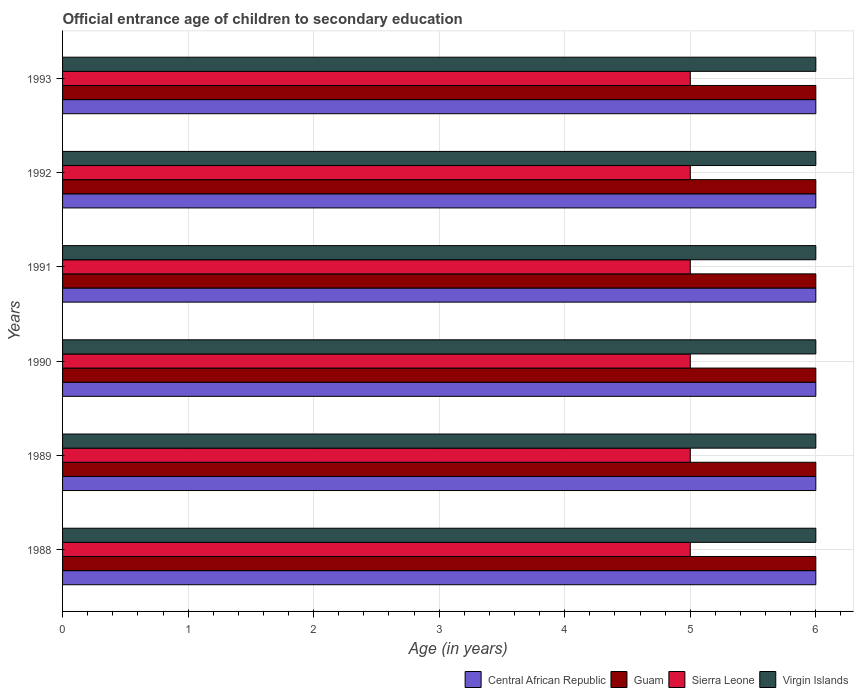How many different coloured bars are there?
Your answer should be compact. 4. Are the number of bars per tick equal to the number of legend labels?
Keep it short and to the point. Yes. How many bars are there on the 2nd tick from the top?
Make the answer very short. 4. How many bars are there on the 1st tick from the bottom?
Make the answer very short. 4. What is the label of the 3rd group of bars from the top?
Ensure brevity in your answer.  1991. In how many cases, is the number of bars for a given year not equal to the number of legend labels?
Ensure brevity in your answer.  0. What is the secondary school starting age of children in Sierra Leone in 1993?
Give a very brief answer. 5. Across all years, what is the maximum secondary school starting age of children in Sierra Leone?
Offer a terse response. 5. Across all years, what is the minimum secondary school starting age of children in Guam?
Make the answer very short. 6. In which year was the secondary school starting age of children in Sierra Leone maximum?
Keep it short and to the point. 1988. What is the total secondary school starting age of children in Virgin Islands in the graph?
Provide a short and direct response. 36. What is the difference between the secondary school starting age of children in Guam in 1989 and that in 1993?
Provide a succinct answer. 0. What is the difference between the secondary school starting age of children in Virgin Islands in 1992 and the secondary school starting age of children in Central African Republic in 1989?
Offer a very short reply. 0. In the year 1990, what is the difference between the secondary school starting age of children in Sierra Leone and secondary school starting age of children in Central African Republic?
Your answer should be compact. -1. In how many years, is the secondary school starting age of children in Guam greater than 3.2 years?
Offer a very short reply. 6. What is the ratio of the secondary school starting age of children in Virgin Islands in 1990 to that in 1991?
Make the answer very short. 1. Is the difference between the secondary school starting age of children in Sierra Leone in 1989 and 1990 greater than the difference between the secondary school starting age of children in Central African Republic in 1989 and 1990?
Give a very brief answer. No. Is the sum of the secondary school starting age of children in Guam in 1989 and 1991 greater than the maximum secondary school starting age of children in Central African Republic across all years?
Your response must be concise. Yes. Is it the case that in every year, the sum of the secondary school starting age of children in Virgin Islands and secondary school starting age of children in Central African Republic is greater than the sum of secondary school starting age of children in Sierra Leone and secondary school starting age of children in Guam?
Offer a terse response. No. What does the 1st bar from the top in 1991 represents?
Offer a very short reply. Virgin Islands. What does the 3rd bar from the bottom in 1989 represents?
Ensure brevity in your answer.  Sierra Leone. Is it the case that in every year, the sum of the secondary school starting age of children in Central African Republic and secondary school starting age of children in Sierra Leone is greater than the secondary school starting age of children in Virgin Islands?
Keep it short and to the point. Yes. How many bars are there?
Ensure brevity in your answer.  24. How many years are there in the graph?
Your answer should be compact. 6. What is the difference between two consecutive major ticks on the X-axis?
Ensure brevity in your answer.  1. How are the legend labels stacked?
Offer a terse response. Horizontal. What is the title of the graph?
Provide a succinct answer. Official entrance age of children to secondary education. Does "Palau" appear as one of the legend labels in the graph?
Provide a short and direct response. No. What is the label or title of the X-axis?
Offer a terse response. Age (in years). What is the Age (in years) of Central African Republic in 1988?
Provide a succinct answer. 6. What is the Age (in years) in Guam in 1988?
Your answer should be compact. 6. What is the Age (in years) in Central African Republic in 1989?
Keep it short and to the point. 6. What is the Age (in years) of Guam in 1990?
Your answer should be compact. 6. What is the Age (in years) of Central African Republic in 1991?
Your response must be concise. 6. What is the Age (in years) of Sierra Leone in 1991?
Offer a terse response. 5. What is the Age (in years) of Central African Republic in 1992?
Make the answer very short. 6. What is the Age (in years) in Guam in 1992?
Ensure brevity in your answer.  6. What is the Age (in years) in Central African Republic in 1993?
Your answer should be very brief. 6. What is the Age (in years) in Guam in 1993?
Ensure brevity in your answer.  6. What is the Age (in years) in Sierra Leone in 1993?
Your answer should be very brief. 5. Across all years, what is the maximum Age (in years) in Guam?
Ensure brevity in your answer.  6. Across all years, what is the maximum Age (in years) in Sierra Leone?
Ensure brevity in your answer.  5. Across all years, what is the maximum Age (in years) in Virgin Islands?
Your answer should be compact. 6. Across all years, what is the minimum Age (in years) of Guam?
Ensure brevity in your answer.  6. What is the total Age (in years) of Central African Republic in the graph?
Provide a short and direct response. 36. What is the total Age (in years) of Sierra Leone in the graph?
Your answer should be compact. 30. What is the total Age (in years) in Virgin Islands in the graph?
Offer a terse response. 36. What is the difference between the Age (in years) of Central African Republic in 1988 and that in 1989?
Your answer should be very brief. 0. What is the difference between the Age (in years) of Virgin Islands in 1988 and that in 1989?
Keep it short and to the point. 0. What is the difference between the Age (in years) of Central African Republic in 1988 and that in 1990?
Provide a succinct answer. 0. What is the difference between the Age (in years) of Central African Republic in 1988 and that in 1991?
Offer a terse response. 0. What is the difference between the Age (in years) in Virgin Islands in 1988 and that in 1991?
Ensure brevity in your answer.  0. What is the difference between the Age (in years) of Central African Republic in 1988 and that in 1992?
Make the answer very short. 0. What is the difference between the Age (in years) in Sierra Leone in 1988 and that in 1992?
Offer a very short reply. 0. What is the difference between the Age (in years) in Central African Republic in 1988 and that in 1993?
Offer a terse response. 0. What is the difference between the Age (in years) of Guam in 1988 and that in 1993?
Make the answer very short. 0. What is the difference between the Age (in years) in Sierra Leone in 1988 and that in 1993?
Your response must be concise. 0. What is the difference between the Age (in years) in Guam in 1989 and that in 1990?
Make the answer very short. 0. What is the difference between the Age (in years) of Sierra Leone in 1989 and that in 1990?
Your answer should be compact. 0. What is the difference between the Age (in years) of Guam in 1989 and that in 1991?
Your answer should be very brief. 0. What is the difference between the Age (in years) in Sierra Leone in 1989 and that in 1991?
Offer a very short reply. 0. What is the difference between the Age (in years) of Virgin Islands in 1989 and that in 1991?
Your response must be concise. 0. What is the difference between the Age (in years) in Central African Republic in 1989 and that in 1992?
Your answer should be very brief. 0. What is the difference between the Age (in years) of Virgin Islands in 1989 and that in 1992?
Offer a terse response. 0. What is the difference between the Age (in years) in Guam in 1989 and that in 1993?
Ensure brevity in your answer.  0. What is the difference between the Age (in years) of Central African Republic in 1990 and that in 1991?
Offer a very short reply. 0. What is the difference between the Age (in years) in Central African Republic in 1990 and that in 1992?
Give a very brief answer. 0. What is the difference between the Age (in years) of Sierra Leone in 1990 and that in 1992?
Your response must be concise. 0. What is the difference between the Age (in years) in Virgin Islands in 1990 and that in 1992?
Your response must be concise. 0. What is the difference between the Age (in years) in Central African Republic in 1990 and that in 1993?
Offer a terse response. 0. What is the difference between the Age (in years) in Virgin Islands in 1990 and that in 1993?
Your response must be concise. 0. What is the difference between the Age (in years) of Guam in 1991 and that in 1992?
Keep it short and to the point. 0. What is the difference between the Age (in years) of Sierra Leone in 1991 and that in 1992?
Keep it short and to the point. 0. What is the difference between the Age (in years) of Guam in 1992 and that in 1993?
Your answer should be compact. 0. What is the difference between the Age (in years) in Sierra Leone in 1992 and that in 1993?
Provide a succinct answer. 0. What is the difference between the Age (in years) of Central African Republic in 1988 and the Age (in years) of Guam in 1989?
Your answer should be compact. 0. What is the difference between the Age (in years) of Central African Republic in 1988 and the Age (in years) of Virgin Islands in 1989?
Give a very brief answer. 0. What is the difference between the Age (in years) in Central African Republic in 1988 and the Age (in years) in Virgin Islands in 1990?
Offer a terse response. 0. What is the difference between the Age (in years) of Guam in 1988 and the Age (in years) of Sierra Leone in 1990?
Give a very brief answer. 1. What is the difference between the Age (in years) in Guam in 1988 and the Age (in years) in Virgin Islands in 1990?
Offer a terse response. 0. What is the difference between the Age (in years) in Sierra Leone in 1988 and the Age (in years) in Virgin Islands in 1990?
Your response must be concise. -1. What is the difference between the Age (in years) in Central African Republic in 1988 and the Age (in years) in Guam in 1991?
Your response must be concise. 0. What is the difference between the Age (in years) of Central African Republic in 1988 and the Age (in years) of Sierra Leone in 1991?
Ensure brevity in your answer.  1. What is the difference between the Age (in years) of Guam in 1988 and the Age (in years) of Sierra Leone in 1991?
Make the answer very short. 1. What is the difference between the Age (in years) of Guam in 1988 and the Age (in years) of Virgin Islands in 1991?
Offer a very short reply. 0. What is the difference between the Age (in years) of Central African Republic in 1988 and the Age (in years) of Guam in 1992?
Ensure brevity in your answer.  0. What is the difference between the Age (in years) in Central African Republic in 1988 and the Age (in years) in Sierra Leone in 1992?
Make the answer very short. 1. What is the difference between the Age (in years) of Central African Republic in 1988 and the Age (in years) of Virgin Islands in 1992?
Offer a terse response. 0. What is the difference between the Age (in years) of Guam in 1988 and the Age (in years) of Sierra Leone in 1992?
Your answer should be very brief. 1. What is the difference between the Age (in years) in Guam in 1988 and the Age (in years) in Virgin Islands in 1992?
Offer a very short reply. 0. What is the difference between the Age (in years) in Sierra Leone in 1988 and the Age (in years) in Virgin Islands in 1992?
Your response must be concise. -1. What is the difference between the Age (in years) in Central African Republic in 1988 and the Age (in years) in Sierra Leone in 1993?
Keep it short and to the point. 1. What is the difference between the Age (in years) in Guam in 1988 and the Age (in years) in Virgin Islands in 1993?
Offer a terse response. 0. What is the difference between the Age (in years) in Central African Republic in 1989 and the Age (in years) in Virgin Islands in 1990?
Offer a very short reply. 0. What is the difference between the Age (in years) in Central African Republic in 1989 and the Age (in years) in Sierra Leone in 1991?
Provide a short and direct response. 1. What is the difference between the Age (in years) in Central African Republic in 1989 and the Age (in years) in Virgin Islands in 1991?
Offer a terse response. 0. What is the difference between the Age (in years) of Central African Republic in 1989 and the Age (in years) of Guam in 1992?
Keep it short and to the point. 0. What is the difference between the Age (in years) of Guam in 1989 and the Age (in years) of Virgin Islands in 1992?
Your response must be concise. 0. What is the difference between the Age (in years) in Sierra Leone in 1989 and the Age (in years) in Virgin Islands in 1992?
Provide a short and direct response. -1. What is the difference between the Age (in years) of Central African Republic in 1989 and the Age (in years) of Guam in 1993?
Make the answer very short. 0. What is the difference between the Age (in years) of Central African Republic in 1989 and the Age (in years) of Virgin Islands in 1993?
Ensure brevity in your answer.  0. What is the difference between the Age (in years) of Guam in 1989 and the Age (in years) of Sierra Leone in 1993?
Offer a very short reply. 1. What is the difference between the Age (in years) of Sierra Leone in 1989 and the Age (in years) of Virgin Islands in 1993?
Offer a very short reply. -1. What is the difference between the Age (in years) in Central African Republic in 1990 and the Age (in years) in Guam in 1991?
Make the answer very short. 0. What is the difference between the Age (in years) in Central African Republic in 1990 and the Age (in years) in Sierra Leone in 1991?
Offer a terse response. 1. What is the difference between the Age (in years) in Central African Republic in 1990 and the Age (in years) in Virgin Islands in 1991?
Your response must be concise. 0. What is the difference between the Age (in years) of Guam in 1990 and the Age (in years) of Sierra Leone in 1991?
Your answer should be very brief. 1. What is the difference between the Age (in years) in Guam in 1990 and the Age (in years) in Virgin Islands in 1991?
Your answer should be very brief. 0. What is the difference between the Age (in years) of Sierra Leone in 1990 and the Age (in years) of Virgin Islands in 1991?
Provide a succinct answer. -1. What is the difference between the Age (in years) of Central African Republic in 1990 and the Age (in years) of Guam in 1992?
Offer a very short reply. 0. What is the difference between the Age (in years) in Central African Republic in 1990 and the Age (in years) in Sierra Leone in 1992?
Offer a very short reply. 1. What is the difference between the Age (in years) in Guam in 1990 and the Age (in years) in Sierra Leone in 1992?
Your answer should be compact. 1. What is the difference between the Age (in years) of Guam in 1990 and the Age (in years) of Virgin Islands in 1992?
Your answer should be very brief. 0. What is the difference between the Age (in years) in Sierra Leone in 1990 and the Age (in years) in Virgin Islands in 1992?
Provide a succinct answer. -1. What is the difference between the Age (in years) of Central African Republic in 1990 and the Age (in years) of Sierra Leone in 1993?
Ensure brevity in your answer.  1. What is the difference between the Age (in years) in Central African Republic in 1990 and the Age (in years) in Virgin Islands in 1993?
Keep it short and to the point. 0. What is the difference between the Age (in years) in Guam in 1991 and the Age (in years) in Sierra Leone in 1992?
Offer a terse response. 1. What is the difference between the Age (in years) in Sierra Leone in 1991 and the Age (in years) in Virgin Islands in 1992?
Your answer should be very brief. -1. What is the difference between the Age (in years) in Central African Republic in 1991 and the Age (in years) in Virgin Islands in 1993?
Keep it short and to the point. 0. What is the difference between the Age (in years) in Guam in 1991 and the Age (in years) in Sierra Leone in 1993?
Make the answer very short. 1. What is the difference between the Age (in years) of Guam in 1991 and the Age (in years) of Virgin Islands in 1993?
Your answer should be very brief. 0. What is the difference between the Age (in years) in Sierra Leone in 1991 and the Age (in years) in Virgin Islands in 1993?
Ensure brevity in your answer.  -1. What is the difference between the Age (in years) of Guam in 1992 and the Age (in years) of Sierra Leone in 1993?
Your response must be concise. 1. What is the difference between the Age (in years) of Sierra Leone in 1992 and the Age (in years) of Virgin Islands in 1993?
Make the answer very short. -1. What is the average Age (in years) of Guam per year?
Your answer should be very brief. 6. What is the average Age (in years) in Sierra Leone per year?
Ensure brevity in your answer.  5. In the year 1988, what is the difference between the Age (in years) in Guam and Age (in years) in Sierra Leone?
Give a very brief answer. 1. In the year 1988, what is the difference between the Age (in years) in Guam and Age (in years) in Virgin Islands?
Make the answer very short. 0. In the year 1988, what is the difference between the Age (in years) in Sierra Leone and Age (in years) in Virgin Islands?
Ensure brevity in your answer.  -1. In the year 1989, what is the difference between the Age (in years) of Central African Republic and Age (in years) of Guam?
Offer a very short reply. 0. In the year 1989, what is the difference between the Age (in years) in Guam and Age (in years) in Virgin Islands?
Your answer should be compact. 0. In the year 1989, what is the difference between the Age (in years) of Sierra Leone and Age (in years) of Virgin Islands?
Your answer should be very brief. -1. In the year 1990, what is the difference between the Age (in years) in Central African Republic and Age (in years) in Guam?
Offer a very short reply. 0. In the year 1990, what is the difference between the Age (in years) in Central African Republic and Age (in years) in Virgin Islands?
Your answer should be very brief. 0. In the year 1990, what is the difference between the Age (in years) of Guam and Age (in years) of Virgin Islands?
Make the answer very short. 0. In the year 1990, what is the difference between the Age (in years) in Sierra Leone and Age (in years) in Virgin Islands?
Your answer should be very brief. -1. In the year 1991, what is the difference between the Age (in years) in Central African Republic and Age (in years) in Sierra Leone?
Your response must be concise. 1. In the year 1991, what is the difference between the Age (in years) in Central African Republic and Age (in years) in Virgin Islands?
Offer a very short reply. 0. In the year 1991, what is the difference between the Age (in years) of Guam and Age (in years) of Virgin Islands?
Keep it short and to the point. 0. In the year 1991, what is the difference between the Age (in years) in Sierra Leone and Age (in years) in Virgin Islands?
Ensure brevity in your answer.  -1. In the year 1992, what is the difference between the Age (in years) of Central African Republic and Age (in years) of Guam?
Give a very brief answer. 0. In the year 1993, what is the difference between the Age (in years) in Central African Republic and Age (in years) in Guam?
Offer a very short reply. 0. In the year 1993, what is the difference between the Age (in years) of Central African Republic and Age (in years) of Sierra Leone?
Offer a very short reply. 1. In the year 1993, what is the difference between the Age (in years) of Central African Republic and Age (in years) of Virgin Islands?
Make the answer very short. 0. In the year 1993, what is the difference between the Age (in years) of Guam and Age (in years) of Sierra Leone?
Your response must be concise. 1. What is the ratio of the Age (in years) of Virgin Islands in 1988 to that in 1990?
Offer a very short reply. 1. What is the ratio of the Age (in years) in Guam in 1988 to that in 1991?
Ensure brevity in your answer.  1. What is the ratio of the Age (in years) of Sierra Leone in 1988 to that in 1991?
Offer a very short reply. 1. What is the ratio of the Age (in years) in Virgin Islands in 1988 to that in 1991?
Your answer should be very brief. 1. What is the ratio of the Age (in years) of Sierra Leone in 1988 to that in 1992?
Provide a short and direct response. 1. What is the ratio of the Age (in years) in Sierra Leone in 1988 to that in 1993?
Provide a short and direct response. 1. What is the ratio of the Age (in years) of Central African Republic in 1989 to that in 1990?
Your answer should be very brief. 1. What is the ratio of the Age (in years) in Guam in 1989 to that in 1990?
Provide a succinct answer. 1. What is the ratio of the Age (in years) in Virgin Islands in 1989 to that in 1990?
Keep it short and to the point. 1. What is the ratio of the Age (in years) in Guam in 1989 to that in 1991?
Ensure brevity in your answer.  1. What is the ratio of the Age (in years) of Sierra Leone in 1989 to that in 1991?
Ensure brevity in your answer.  1. What is the ratio of the Age (in years) of Virgin Islands in 1989 to that in 1991?
Offer a very short reply. 1. What is the ratio of the Age (in years) in Guam in 1989 to that in 1992?
Give a very brief answer. 1. What is the ratio of the Age (in years) of Virgin Islands in 1989 to that in 1992?
Keep it short and to the point. 1. What is the ratio of the Age (in years) of Central African Republic in 1989 to that in 1993?
Make the answer very short. 1. What is the ratio of the Age (in years) in Sierra Leone in 1989 to that in 1993?
Provide a short and direct response. 1. What is the ratio of the Age (in years) in Virgin Islands in 1989 to that in 1993?
Provide a short and direct response. 1. What is the ratio of the Age (in years) of Guam in 1990 to that in 1991?
Ensure brevity in your answer.  1. What is the ratio of the Age (in years) of Sierra Leone in 1990 to that in 1991?
Ensure brevity in your answer.  1. What is the ratio of the Age (in years) in Sierra Leone in 1990 to that in 1992?
Give a very brief answer. 1. What is the ratio of the Age (in years) in Guam in 1990 to that in 1993?
Give a very brief answer. 1. What is the ratio of the Age (in years) in Virgin Islands in 1990 to that in 1993?
Offer a very short reply. 1. What is the ratio of the Age (in years) in Guam in 1991 to that in 1992?
Offer a very short reply. 1. What is the ratio of the Age (in years) of Central African Republic in 1991 to that in 1993?
Your answer should be very brief. 1. What is the ratio of the Age (in years) in Guam in 1991 to that in 1993?
Provide a succinct answer. 1. What is the ratio of the Age (in years) of Sierra Leone in 1991 to that in 1993?
Your response must be concise. 1. What is the ratio of the Age (in years) in Virgin Islands in 1991 to that in 1993?
Your response must be concise. 1. What is the ratio of the Age (in years) of Central African Republic in 1992 to that in 1993?
Ensure brevity in your answer.  1. What is the ratio of the Age (in years) in Guam in 1992 to that in 1993?
Your response must be concise. 1. What is the difference between the highest and the second highest Age (in years) of Guam?
Give a very brief answer. 0. What is the difference between the highest and the second highest Age (in years) of Sierra Leone?
Your answer should be very brief. 0. What is the difference between the highest and the second highest Age (in years) in Virgin Islands?
Your response must be concise. 0. What is the difference between the highest and the lowest Age (in years) in Virgin Islands?
Your answer should be compact. 0. 